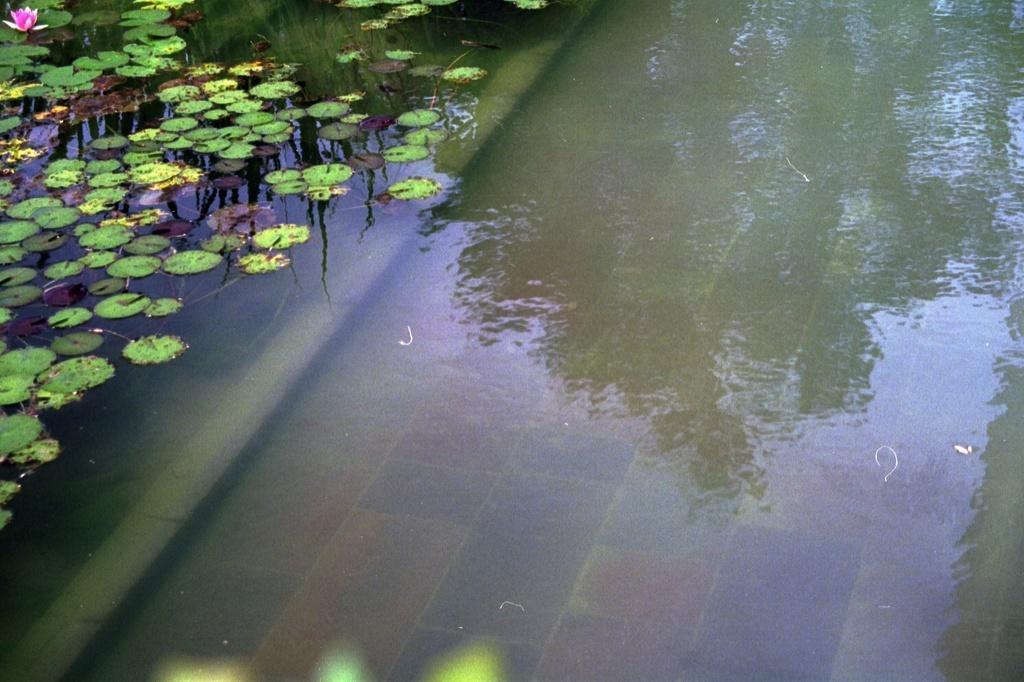What is happening to the plants in the image? The plants are in the water in the image. Can you describe the flower in the image? There is a flower in the image. What is the name of the nation where the brothers are shopping in the image? There are no nations, stores, or brothers present in the image; it features plants in the water and a flower. 